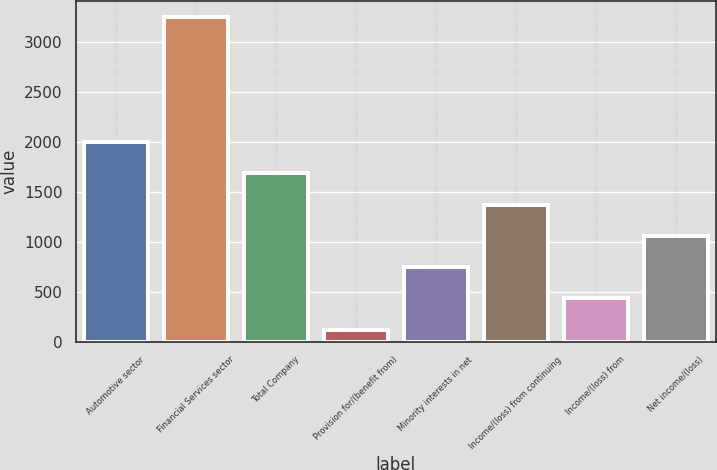Convert chart to OTSL. <chart><loc_0><loc_0><loc_500><loc_500><bar_chart><fcel>Automotive sector<fcel>Financial Services sector<fcel>Total Company<fcel>Provision for/(benefit from)<fcel>Minority interests in net<fcel>Income/(loss) from continuing<fcel>Income/(loss) from<fcel>Net income/(loss)<nl><fcel>1997.4<fcel>3247<fcel>1685<fcel>123<fcel>747.8<fcel>1372.6<fcel>435.4<fcel>1060.2<nl></chart> 